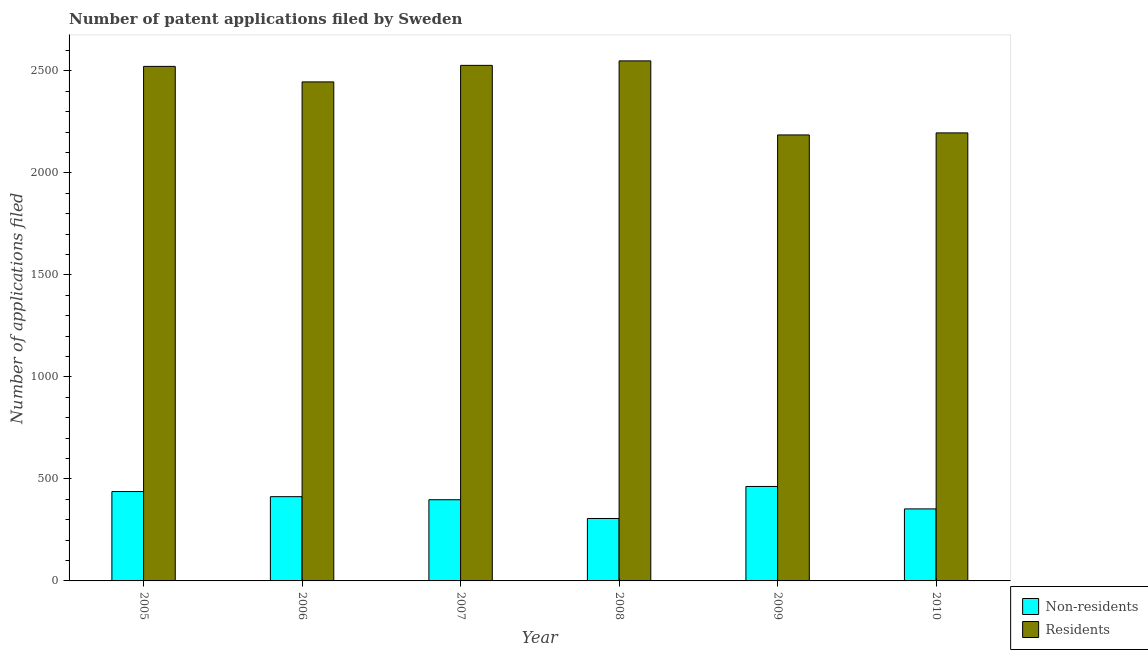How many different coloured bars are there?
Give a very brief answer. 2. Are the number of bars per tick equal to the number of legend labels?
Offer a terse response. Yes. How many bars are there on the 1st tick from the right?
Give a very brief answer. 2. What is the label of the 4th group of bars from the left?
Ensure brevity in your answer.  2008. What is the number of patent applications by non residents in 2010?
Your response must be concise. 353. Across all years, what is the maximum number of patent applications by residents?
Offer a terse response. 2549. Across all years, what is the minimum number of patent applications by non residents?
Offer a terse response. 306. In which year was the number of patent applications by non residents maximum?
Your answer should be very brief. 2009. What is the total number of patent applications by residents in the graph?
Provide a succinct answer. 1.44e+04. What is the difference between the number of patent applications by non residents in 2005 and that in 2006?
Give a very brief answer. 25. What is the difference between the number of patent applications by residents in 2005 and the number of patent applications by non residents in 2007?
Provide a succinct answer. -5. What is the average number of patent applications by non residents per year?
Make the answer very short. 395.17. In the year 2008, what is the difference between the number of patent applications by non residents and number of patent applications by residents?
Your answer should be very brief. 0. What is the ratio of the number of patent applications by non residents in 2007 to that in 2009?
Your answer should be compact. 0.86. What is the difference between the highest and the second highest number of patent applications by non residents?
Your answer should be very brief. 25. What is the difference between the highest and the lowest number of patent applications by residents?
Your answer should be very brief. 363. What does the 2nd bar from the left in 2006 represents?
Your answer should be compact. Residents. What does the 2nd bar from the right in 2009 represents?
Your answer should be very brief. Non-residents. Are all the bars in the graph horizontal?
Your response must be concise. No. Does the graph contain grids?
Keep it short and to the point. No. How many legend labels are there?
Your response must be concise. 2. What is the title of the graph?
Your answer should be very brief. Number of patent applications filed by Sweden. What is the label or title of the Y-axis?
Offer a terse response. Number of applications filed. What is the Number of applications filed of Non-residents in 2005?
Provide a succinct answer. 438. What is the Number of applications filed of Residents in 2005?
Your answer should be very brief. 2522. What is the Number of applications filed of Non-residents in 2006?
Keep it short and to the point. 413. What is the Number of applications filed in Residents in 2006?
Offer a terse response. 2446. What is the Number of applications filed of Non-residents in 2007?
Provide a short and direct response. 398. What is the Number of applications filed in Residents in 2007?
Give a very brief answer. 2527. What is the Number of applications filed of Non-residents in 2008?
Your response must be concise. 306. What is the Number of applications filed in Residents in 2008?
Provide a succinct answer. 2549. What is the Number of applications filed of Non-residents in 2009?
Provide a succinct answer. 463. What is the Number of applications filed of Residents in 2009?
Provide a succinct answer. 2186. What is the Number of applications filed in Non-residents in 2010?
Keep it short and to the point. 353. What is the Number of applications filed in Residents in 2010?
Offer a very short reply. 2196. Across all years, what is the maximum Number of applications filed of Non-residents?
Ensure brevity in your answer.  463. Across all years, what is the maximum Number of applications filed of Residents?
Offer a terse response. 2549. Across all years, what is the minimum Number of applications filed in Non-residents?
Your response must be concise. 306. Across all years, what is the minimum Number of applications filed in Residents?
Your answer should be very brief. 2186. What is the total Number of applications filed in Non-residents in the graph?
Give a very brief answer. 2371. What is the total Number of applications filed of Residents in the graph?
Your answer should be very brief. 1.44e+04. What is the difference between the Number of applications filed in Residents in 2005 and that in 2006?
Provide a succinct answer. 76. What is the difference between the Number of applications filed of Non-residents in 2005 and that in 2007?
Keep it short and to the point. 40. What is the difference between the Number of applications filed in Residents in 2005 and that in 2007?
Your answer should be very brief. -5. What is the difference between the Number of applications filed in Non-residents in 2005 and that in 2008?
Provide a short and direct response. 132. What is the difference between the Number of applications filed of Residents in 2005 and that in 2008?
Offer a terse response. -27. What is the difference between the Number of applications filed of Residents in 2005 and that in 2009?
Offer a very short reply. 336. What is the difference between the Number of applications filed in Non-residents in 2005 and that in 2010?
Ensure brevity in your answer.  85. What is the difference between the Number of applications filed in Residents in 2005 and that in 2010?
Your answer should be very brief. 326. What is the difference between the Number of applications filed of Residents in 2006 and that in 2007?
Your response must be concise. -81. What is the difference between the Number of applications filed of Non-residents in 2006 and that in 2008?
Keep it short and to the point. 107. What is the difference between the Number of applications filed of Residents in 2006 and that in 2008?
Your response must be concise. -103. What is the difference between the Number of applications filed of Non-residents in 2006 and that in 2009?
Give a very brief answer. -50. What is the difference between the Number of applications filed of Residents in 2006 and that in 2009?
Offer a terse response. 260. What is the difference between the Number of applications filed in Non-residents in 2006 and that in 2010?
Offer a very short reply. 60. What is the difference between the Number of applications filed of Residents in 2006 and that in 2010?
Offer a terse response. 250. What is the difference between the Number of applications filed in Non-residents in 2007 and that in 2008?
Keep it short and to the point. 92. What is the difference between the Number of applications filed in Residents in 2007 and that in 2008?
Ensure brevity in your answer.  -22. What is the difference between the Number of applications filed in Non-residents in 2007 and that in 2009?
Your response must be concise. -65. What is the difference between the Number of applications filed of Residents in 2007 and that in 2009?
Offer a very short reply. 341. What is the difference between the Number of applications filed in Residents in 2007 and that in 2010?
Offer a terse response. 331. What is the difference between the Number of applications filed in Non-residents in 2008 and that in 2009?
Provide a short and direct response. -157. What is the difference between the Number of applications filed of Residents in 2008 and that in 2009?
Offer a very short reply. 363. What is the difference between the Number of applications filed of Non-residents in 2008 and that in 2010?
Ensure brevity in your answer.  -47. What is the difference between the Number of applications filed in Residents in 2008 and that in 2010?
Provide a succinct answer. 353. What is the difference between the Number of applications filed of Non-residents in 2009 and that in 2010?
Your response must be concise. 110. What is the difference between the Number of applications filed of Non-residents in 2005 and the Number of applications filed of Residents in 2006?
Keep it short and to the point. -2008. What is the difference between the Number of applications filed in Non-residents in 2005 and the Number of applications filed in Residents in 2007?
Ensure brevity in your answer.  -2089. What is the difference between the Number of applications filed of Non-residents in 2005 and the Number of applications filed of Residents in 2008?
Make the answer very short. -2111. What is the difference between the Number of applications filed of Non-residents in 2005 and the Number of applications filed of Residents in 2009?
Provide a short and direct response. -1748. What is the difference between the Number of applications filed in Non-residents in 2005 and the Number of applications filed in Residents in 2010?
Offer a very short reply. -1758. What is the difference between the Number of applications filed in Non-residents in 2006 and the Number of applications filed in Residents in 2007?
Provide a short and direct response. -2114. What is the difference between the Number of applications filed of Non-residents in 2006 and the Number of applications filed of Residents in 2008?
Give a very brief answer. -2136. What is the difference between the Number of applications filed in Non-residents in 2006 and the Number of applications filed in Residents in 2009?
Your answer should be compact. -1773. What is the difference between the Number of applications filed in Non-residents in 2006 and the Number of applications filed in Residents in 2010?
Make the answer very short. -1783. What is the difference between the Number of applications filed in Non-residents in 2007 and the Number of applications filed in Residents in 2008?
Your answer should be very brief. -2151. What is the difference between the Number of applications filed in Non-residents in 2007 and the Number of applications filed in Residents in 2009?
Keep it short and to the point. -1788. What is the difference between the Number of applications filed in Non-residents in 2007 and the Number of applications filed in Residents in 2010?
Keep it short and to the point. -1798. What is the difference between the Number of applications filed in Non-residents in 2008 and the Number of applications filed in Residents in 2009?
Your answer should be very brief. -1880. What is the difference between the Number of applications filed in Non-residents in 2008 and the Number of applications filed in Residents in 2010?
Provide a short and direct response. -1890. What is the difference between the Number of applications filed in Non-residents in 2009 and the Number of applications filed in Residents in 2010?
Make the answer very short. -1733. What is the average Number of applications filed of Non-residents per year?
Give a very brief answer. 395.17. What is the average Number of applications filed in Residents per year?
Ensure brevity in your answer.  2404.33. In the year 2005, what is the difference between the Number of applications filed of Non-residents and Number of applications filed of Residents?
Your response must be concise. -2084. In the year 2006, what is the difference between the Number of applications filed in Non-residents and Number of applications filed in Residents?
Your response must be concise. -2033. In the year 2007, what is the difference between the Number of applications filed in Non-residents and Number of applications filed in Residents?
Your answer should be compact. -2129. In the year 2008, what is the difference between the Number of applications filed of Non-residents and Number of applications filed of Residents?
Give a very brief answer. -2243. In the year 2009, what is the difference between the Number of applications filed in Non-residents and Number of applications filed in Residents?
Your answer should be very brief. -1723. In the year 2010, what is the difference between the Number of applications filed in Non-residents and Number of applications filed in Residents?
Keep it short and to the point. -1843. What is the ratio of the Number of applications filed of Non-residents in 2005 to that in 2006?
Offer a very short reply. 1.06. What is the ratio of the Number of applications filed in Residents in 2005 to that in 2006?
Provide a succinct answer. 1.03. What is the ratio of the Number of applications filed of Non-residents in 2005 to that in 2007?
Give a very brief answer. 1.1. What is the ratio of the Number of applications filed of Residents in 2005 to that in 2007?
Your answer should be very brief. 1. What is the ratio of the Number of applications filed in Non-residents in 2005 to that in 2008?
Keep it short and to the point. 1.43. What is the ratio of the Number of applications filed in Residents in 2005 to that in 2008?
Offer a very short reply. 0.99. What is the ratio of the Number of applications filed in Non-residents in 2005 to that in 2009?
Keep it short and to the point. 0.95. What is the ratio of the Number of applications filed of Residents in 2005 to that in 2009?
Offer a very short reply. 1.15. What is the ratio of the Number of applications filed in Non-residents in 2005 to that in 2010?
Offer a terse response. 1.24. What is the ratio of the Number of applications filed of Residents in 2005 to that in 2010?
Keep it short and to the point. 1.15. What is the ratio of the Number of applications filed of Non-residents in 2006 to that in 2007?
Your response must be concise. 1.04. What is the ratio of the Number of applications filed of Residents in 2006 to that in 2007?
Give a very brief answer. 0.97. What is the ratio of the Number of applications filed of Non-residents in 2006 to that in 2008?
Your answer should be compact. 1.35. What is the ratio of the Number of applications filed of Residents in 2006 to that in 2008?
Keep it short and to the point. 0.96. What is the ratio of the Number of applications filed of Non-residents in 2006 to that in 2009?
Offer a terse response. 0.89. What is the ratio of the Number of applications filed in Residents in 2006 to that in 2009?
Give a very brief answer. 1.12. What is the ratio of the Number of applications filed in Non-residents in 2006 to that in 2010?
Ensure brevity in your answer.  1.17. What is the ratio of the Number of applications filed in Residents in 2006 to that in 2010?
Provide a succinct answer. 1.11. What is the ratio of the Number of applications filed of Non-residents in 2007 to that in 2008?
Provide a short and direct response. 1.3. What is the ratio of the Number of applications filed in Residents in 2007 to that in 2008?
Provide a succinct answer. 0.99. What is the ratio of the Number of applications filed in Non-residents in 2007 to that in 2009?
Provide a succinct answer. 0.86. What is the ratio of the Number of applications filed of Residents in 2007 to that in 2009?
Offer a very short reply. 1.16. What is the ratio of the Number of applications filed of Non-residents in 2007 to that in 2010?
Offer a very short reply. 1.13. What is the ratio of the Number of applications filed in Residents in 2007 to that in 2010?
Your answer should be compact. 1.15. What is the ratio of the Number of applications filed of Non-residents in 2008 to that in 2009?
Your answer should be very brief. 0.66. What is the ratio of the Number of applications filed in Residents in 2008 to that in 2009?
Your answer should be compact. 1.17. What is the ratio of the Number of applications filed of Non-residents in 2008 to that in 2010?
Your response must be concise. 0.87. What is the ratio of the Number of applications filed of Residents in 2008 to that in 2010?
Ensure brevity in your answer.  1.16. What is the ratio of the Number of applications filed in Non-residents in 2009 to that in 2010?
Keep it short and to the point. 1.31. What is the ratio of the Number of applications filed in Residents in 2009 to that in 2010?
Your answer should be compact. 1. What is the difference between the highest and the lowest Number of applications filed of Non-residents?
Give a very brief answer. 157. What is the difference between the highest and the lowest Number of applications filed in Residents?
Your answer should be compact. 363. 